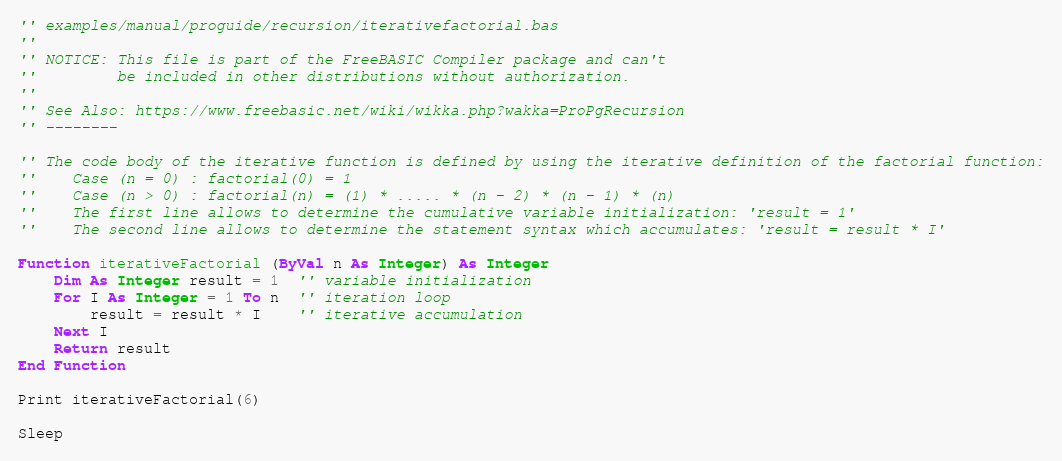Convert code to text. <code><loc_0><loc_0><loc_500><loc_500><_VisualBasic_>'' examples/manual/proguide/recursion/iterativefactorial.bas
''
'' NOTICE: This file is part of the FreeBASIC Compiler package and can't
''         be included in other distributions without authorization.
''
'' See Also: https://www.freebasic.net/wiki/wikka.php?wakka=ProPgRecursion
'' --------

'' The code body of the iterative function is defined by using the iterative definition of the factorial function:
''    Case (n = 0) : factorial(0) = 1
''    Case (n > 0) : factorial(n) = (1) * ..... * (n - 2) * (n - 1) * (n)
''    The first line allows to determine the cumulative variable initialization: 'result = 1'
''    The second line allows to determine the statement syntax which accumulates: 'result = result * I'

Function iterativeFactorial (ByVal n As Integer) As Integer
	Dim As Integer result = 1  '' variable initialization
	For I As Integer = 1 To n  '' iteration loop
		result = result * I    '' iterative accumulation
	Next I
	Return result
End Function

Print iterativeFactorial(6)

Sleep
</code> 